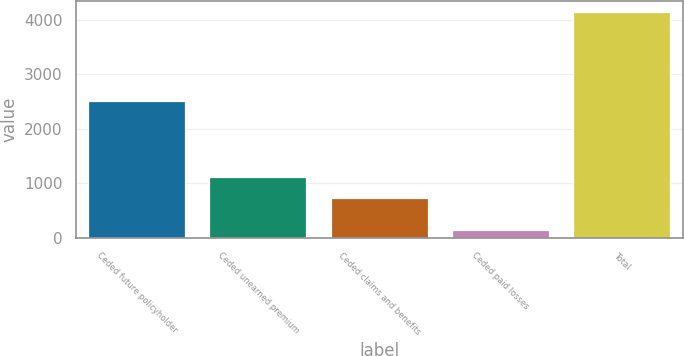<chart> <loc_0><loc_0><loc_500><loc_500><bar_chart><fcel>Ceded future policyholder<fcel>Ceded unearned premium<fcel>Ceded claims and benefits<fcel>Ceded paid losses<fcel>Total<nl><fcel>2504<fcel>1119.1<fcel>720<fcel>142<fcel>4133<nl></chart> 